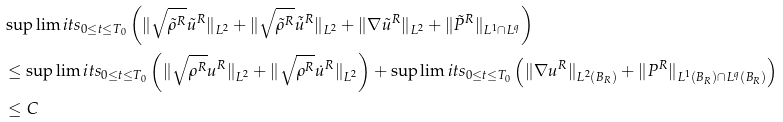Convert formula to latex. <formula><loc_0><loc_0><loc_500><loc_500>& \sup \lim i t s _ { 0 \leq t \leq T _ { 0 } } \left ( \| \sqrt { \tilde { \rho } ^ { R } } \tilde { u } ^ { R } \| _ { L ^ { 2 } } + \| \sqrt { \tilde { \rho } ^ { R } } \tilde { \dot { u } } ^ { R } \| _ { L ^ { 2 } } + \| \nabla \tilde { u } ^ { R } \| _ { L ^ { 2 } } + \| \tilde { P } ^ { R } \| _ { L ^ { 1 } \cap L ^ { q } } \right ) \\ & \leq \sup \lim i t s _ { 0 \leq t \leq T _ { 0 } } \left ( \| \sqrt { \rho ^ { R } } u ^ { R } \| _ { L ^ { 2 } } + \| \sqrt { \rho ^ { R } } \dot { u } ^ { R } \| _ { L ^ { 2 } } \right ) + \sup \lim i t s _ { 0 \leq t \leq T _ { 0 } } \left ( \| \nabla u ^ { R } \| _ { L ^ { 2 } ( B _ { R } ) } + \| P ^ { R } \| _ { L ^ { 1 } ( B _ { R } ) \cap L ^ { q } ( B _ { R } ) } \right ) \\ & \leq C</formula> 